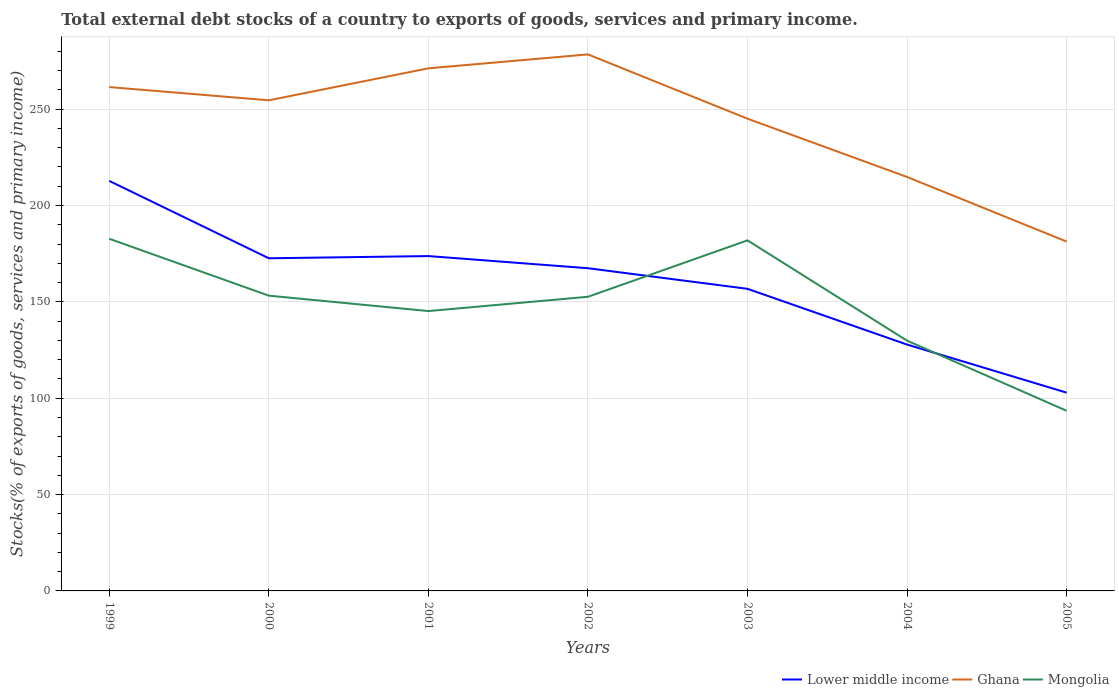How many different coloured lines are there?
Make the answer very short. 3. Is the number of lines equal to the number of legend labels?
Give a very brief answer. Yes. Across all years, what is the maximum total debt stocks in Ghana?
Provide a succinct answer. 181.31. In which year was the total debt stocks in Mongolia maximum?
Make the answer very short. 2005. What is the total total debt stocks in Lower middle income in the graph?
Your answer should be compact. 15.85. What is the difference between the highest and the second highest total debt stocks in Ghana?
Make the answer very short. 97.12. What is the difference between the highest and the lowest total debt stocks in Lower middle income?
Keep it short and to the point. 4. How many lines are there?
Make the answer very short. 3. How many years are there in the graph?
Keep it short and to the point. 7. Are the values on the major ticks of Y-axis written in scientific E-notation?
Your response must be concise. No. Does the graph contain any zero values?
Keep it short and to the point. No. Where does the legend appear in the graph?
Keep it short and to the point. Bottom right. How are the legend labels stacked?
Offer a terse response. Horizontal. What is the title of the graph?
Keep it short and to the point. Total external debt stocks of a country to exports of goods, services and primary income. Does "Timor-Leste" appear as one of the legend labels in the graph?
Give a very brief answer. No. What is the label or title of the X-axis?
Give a very brief answer. Years. What is the label or title of the Y-axis?
Offer a very short reply. Stocks(% of exports of goods, services and primary income). What is the Stocks(% of exports of goods, services and primary income) in Lower middle income in 1999?
Provide a succinct answer. 212.78. What is the Stocks(% of exports of goods, services and primary income) in Ghana in 1999?
Ensure brevity in your answer.  261.48. What is the Stocks(% of exports of goods, services and primary income) in Mongolia in 1999?
Provide a succinct answer. 182.75. What is the Stocks(% of exports of goods, services and primary income) of Lower middle income in 2000?
Keep it short and to the point. 172.63. What is the Stocks(% of exports of goods, services and primary income) in Ghana in 2000?
Your answer should be very brief. 254.61. What is the Stocks(% of exports of goods, services and primary income) of Mongolia in 2000?
Offer a terse response. 153.23. What is the Stocks(% of exports of goods, services and primary income) in Lower middle income in 2001?
Offer a terse response. 173.77. What is the Stocks(% of exports of goods, services and primary income) of Ghana in 2001?
Make the answer very short. 271.2. What is the Stocks(% of exports of goods, services and primary income) of Mongolia in 2001?
Provide a succinct answer. 145.24. What is the Stocks(% of exports of goods, services and primary income) in Lower middle income in 2002?
Keep it short and to the point. 167.47. What is the Stocks(% of exports of goods, services and primary income) of Ghana in 2002?
Make the answer very short. 278.43. What is the Stocks(% of exports of goods, services and primary income) of Mongolia in 2002?
Ensure brevity in your answer.  152.65. What is the Stocks(% of exports of goods, services and primary income) in Lower middle income in 2003?
Your answer should be very brief. 156.78. What is the Stocks(% of exports of goods, services and primary income) in Ghana in 2003?
Offer a very short reply. 245.07. What is the Stocks(% of exports of goods, services and primary income) in Mongolia in 2003?
Your response must be concise. 181.92. What is the Stocks(% of exports of goods, services and primary income) of Lower middle income in 2004?
Offer a very short reply. 127.84. What is the Stocks(% of exports of goods, services and primary income) of Ghana in 2004?
Ensure brevity in your answer.  214.82. What is the Stocks(% of exports of goods, services and primary income) of Mongolia in 2004?
Make the answer very short. 129.87. What is the Stocks(% of exports of goods, services and primary income) in Lower middle income in 2005?
Your answer should be compact. 102.9. What is the Stocks(% of exports of goods, services and primary income) of Ghana in 2005?
Your answer should be compact. 181.31. What is the Stocks(% of exports of goods, services and primary income) in Mongolia in 2005?
Your answer should be very brief. 93.48. Across all years, what is the maximum Stocks(% of exports of goods, services and primary income) of Lower middle income?
Your response must be concise. 212.78. Across all years, what is the maximum Stocks(% of exports of goods, services and primary income) of Ghana?
Make the answer very short. 278.43. Across all years, what is the maximum Stocks(% of exports of goods, services and primary income) in Mongolia?
Your answer should be very brief. 182.75. Across all years, what is the minimum Stocks(% of exports of goods, services and primary income) in Lower middle income?
Keep it short and to the point. 102.9. Across all years, what is the minimum Stocks(% of exports of goods, services and primary income) in Ghana?
Offer a very short reply. 181.31. Across all years, what is the minimum Stocks(% of exports of goods, services and primary income) of Mongolia?
Ensure brevity in your answer.  93.48. What is the total Stocks(% of exports of goods, services and primary income) in Lower middle income in the graph?
Offer a terse response. 1114.18. What is the total Stocks(% of exports of goods, services and primary income) in Ghana in the graph?
Your answer should be compact. 1706.92. What is the total Stocks(% of exports of goods, services and primary income) in Mongolia in the graph?
Offer a very short reply. 1039.14. What is the difference between the Stocks(% of exports of goods, services and primary income) of Lower middle income in 1999 and that in 2000?
Offer a terse response. 40.16. What is the difference between the Stocks(% of exports of goods, services and primary income) in Ghana in 1999 and that in 2000?
Make the answer very short. 6.87. What is the difference between the Stocks(% of exports of goods, services and primary income) in Mongolia in 1999 and that in 2000?
Provide a short and direct response. 29.53. What is the difference between the Stocks(% of exports of goods, services and primary income) in Lower middle income in 1999 and that in 2001?
Ensure brevity in your answer.  39.01. What is the difference between the Stocks(% of exports of goods, services and primary income) of Ghana in 1999 and that in 2001?
Your response must be concise. -9.73. What is the difference between the Stocks(% of exports of goods, services and primary income) in Mongolia in 1999 and that in 2001?
Make the answer very short. 37.52. What is the difference between the Stocks(% of exports of goods, services and primary income) of Lower middle income in 1999 and that in 2002?
Make the answer very short. 45.31. What is the difference between the Stocks(% of exports of goods, services and primary income) in Ghana in 1999 and that in 2002?
Your response must be concise. -16.96. What is the difference between the Stocks(% of exports of goods, services and primary income) in Mongolia in 1999 and that in 2002?
Your answer should be very brief. 30.11. What is the difference between the Stocks(% of exports of goods, services and primary income) of Lower middle income in 1999 and that in 2003?
Make the answer very short. 56.01. What is the difference between the Stocks(% of exports of goods, services and primary income) of Ghana in 1999 and that in 2003?
Provide a short and direct response. 16.41. What is the difference between the Stocks(% of exports of goods, services and primary income) of Mongolia in 1999 and that in 2003?
Make the answer very short. 0.83. What is the difference between the Stocks(% of exports of goods, services and primary income) of Lower middle income in 1999 and that in 2004?
Provide a succinct answer. 84.94. What is the difference between the Stocks(% of exports of goods, services and primary income) in Ghana in 1999 and that in 2004?
Your response must be concise. 46.65. What is the difference between the Stocks(% of exports of goods, services and primary income) in Mongolia in 1999 and that in 2004?
Provide a short and direct response. 52.88. What is the difference between the Stocks(% of exports of goods, services and primary income) in Lower middle income in 1999 and that in 2005?
Keep it short and to the point. 109.88. What is the difference between the Stocks(% of exports of goods, services and primary income) of Ghana in 1999 and that in 2005?
Your answer should be compact. 80.16. What is the difference between the Stocks(% of exports of goods, services and primary income) in Mongolia in 1999 and that in 2005?
Keep it short and to the point. 89.27. What is the difference between the Stocks(% of exports of goods, services and primary income) of Lower middle income in 2000 and that in 2001?
Your response must be concise. -1.14. What is the difference between the Stocks(% of exports of goods, services and primary income) in Ghana in 2000 and that in 2001?
Your answer should be compact. -16.6. What is the difference between the Stocks(% of exports of goods, services and primary income) in Mongolia in 2000 and that in 2001?
Provide a short and direct response. 7.99. What is the difference between the Stocks(% of exports of goods, services and primary income) of Lower middle income in 2000 and that in 2002?
Offer a terse response. 5.16. What is the difference between the Stocks(% of exports of goods, services and primary income) in Ghana in 2000 and that in 2002?
Make the answer very short. -23.83. What is the difference between the Stocks(% of exports of goods, services and primary income) in Mongolia in 2000 and that in 2002?
Your response must be concise. 0.58. What is the difference between the Stocks(% of exports of goods, services and primary income) of Lower middle income in 2000 and that in 2003?
Ensure brevity in your answer.  15.85. What is the difference between the Stocks(% of exports of goods, services and primary income) in Ghana in 2000 and that in 2003?
Your response must be concise. 9.54. What is the difference between the Stocks(% of exports of goods, services and primary income) in Mongolia in 2000 and that in 2003?
Offer a terse response. -28.69. What is the difference between the Stocks(% of exports of goods, services and primary income) in Lower middle income in 2000 and that in 2004?
Offer a very short reply. 44.78. What is the difference between the Stocks(% of exports of goods, services and primary income) of Ghana in 2000 and that in 2004?
Ensure brevity in your answer.  39.78. What is the difference between the Stocks(% of exports of goods, services and primary income) of Mongolia in 2000 and that in 2004?
Your answer should be very brief. 23.36. What is the difference between the Stocks(% of exports of goods, services and primary income) in Lower middle income in 2000 and that in 2005?
Your answer should be very brief. 69.73. What is the difference between the Stocks(% of exports of goods, services and primary income) of Ghana in 2000 and that in 2005?
Make the answer very short. 73.29. What is the difference between the Stocks(% of exports of goods, services and primary income) of Mongolia in 2000 and that in 2005?
Provide a succinct answer. 59.75. What is the difference between the Stocks(% of exports of goods, services and primary income) of Lower middle income in 2001 and that in 2002?
Ensure brevity in your answer.  6.3. What is the difference between the Stocks(% of exports of goods, services and primary income) in Ghana in 2001 and that in 2002?
Offer a terse response. -7.23. What is the difference between the Stocks(% of exports of goods, services and primary income) in Mongolia in 2001 and that in 2002?
Keep it short and to the point. -7.41. What is the difference between the Stocks(% of exports of goods, services and primary income) in Lower middle income in 2001 and that in 2003?
Give a very brief answer. 17. What is the difference between the Stocks(% of exports of goods, services and primary income) in Ghana in 2001 and that in 2003?
Keep it short and to the point. 26.14. What is the difference between the Stocks(% of exports of goods, services and primary income) in Mongolia in 2001 and that in 2003?
Your answer should be compact. -36.69. What is the difference between the Stocks(% of exports of goods, services and primary income) of Lower middle income in 2001 and that in 2004?
Make the answer very short. 45.93. What is the difference between the Stocks(% of exports of goods, services and primary income) in Ghana in 2001 and that in 2004?
Your answer should be very brief. 56.38. What is the difference between the Stocks(% of exports of goods, services and primary income) of Mongolia in 2001 and that in 2004?
Your answer should be compact. 15.37. What is the difference between the Stocks(% of exports of goods, services and primary income) in Lower middle income in 2001 and that in 2005?
Keep it short and to the point. 70.87. What is the difference between the Stocks(% of exports of goods, services and primary income) of Ghana in 2001 and that in 2005?
Offer a very short reply. 89.89. What is the difference between the Stocks(% of exports of goods, services and primary income) in Mongolia in 2001 and that in 2005?
Provide a short and direct response. 51.76. What is the difference between the Stocks(% of exports of goods, services and primary income) in Lower middle income in 2002 and that in 2003?
Your answer should be very brief. 10.69. What is the difference between the Stocks(% of exports of goods, services and primary income) in Ghana in 2002 and that in 2003?
Your answer should be very brief. 33.37. What is the difference between the Stocks(% of exports of goods, services and primary income) of Mongolia in 2002 and that in 2003?
Your answer should be very brief. -29.27. What is the difference between the Stocks(% of exports of goods, services and primary income) of Lower middle income in 2002 and that in 2004?
Make the answer very short. 39.63. What is the difference between the Stocks(% of exports of goods, services and primary income) of Ghana in 2002 and that in 2004?
Provide a succinct answer. 63.61. What is the difference between the Stocks(% of exports of goods, services and primary income) in Mongolia in 2002 and that in 2004?
Ensure brevity in your answer.  22.78. What is the difference between the Stocks(% of exports of goods, services and primary income) in Lower middle income in 2002 and that in 2005?
Ensure brevity in your answer.  64.57. What is the difference between the Stocks(% of exports of goods, services and primary income) of Ghana in 2002 and that in 2005?
Your answer should be compact. 97.12. What is the difference between the Stocks(% of exports of goods, services and primary income) in Mongolia in 2002 and that in 2005?
Give a very brief answer. 59.17. What is the difference between the Stocks(% of exports of goods, services and primary income) of Lower middle income in 2003 and that in 2004?
Provide a short and direct response. 28.93. What is the difference between the Stocks(% of exports of goods, services and primary income) of Ghana in 2003 and that in 2004?
Provide a succinct answer. 30.24. What is the difference between the Stocks(% of exports of goods, services and primary income) in Mongolia in 2003 and that in 2004?
Keep it short and to the point. 52.05. What is the difference between the Stocks(% of exports of goods, services and primary income) of Lower middle income in 2003 and that in 2005?
Make the answer very short. 53.87. What is the difference between the Stocks(% of exports of goods, services and primary income) in Ghana in 2003 and that in 2005?
Offer a terse response. 63.75. What is the difference between the Stocks(% of exports of goods, services and primary income) of Mongolia in 2003 and that in 2005?
Offer a very short reply. 88.44. What is the difference between the Stocks(% of exports of goods, services and primary income) in Lower middle income in 2004 and that in 2005?
Give a very brief answer. 24.94. What is the difference between the Stocks(% of exports of goods, services and primary income) of Ghana in 2004 and that in 2005?
Provide a succinct answer. 33.51. What is the difference between the Stocks(% of exports of goods, services and primary income) of Mongolia in 2004 and that in 2005?
Give a very brief answer. 36.39. What is the difference between the Stocks(% of exports of goods, services and primary income) of Lower middle income in 1999 and the Stocks(% of exports of goods, services and primary income) of Ghana in 2000?
Keep it short and to the point. -41.82. What is the difference between the Stocks(% of exports of goods, services and primary income) in Lower middle income in 1999 and the Stocks(% of exports of goods, services and primary income) in Mongolia in 2000?
Provide a short and direct response. 59.56. What is the difference between the Stocks(% of exports of goods, services and primary income) of Ghana in 1999 and the Stocks(% of exports of goods, services and primary income) of Mongolia in 2000?
Your answer should be very brief. 108.25. What is the difference between the Stocks(% of exports of goods, services and primary income) in Lower middle income in 1999 and the Stocks(% of exports of goods, services and primary income) in Ghana in 2001?
Keep it short and to the point. -58.42. What is the difference between the Stocks(% of exports of goods, services and primary income) of Lower middle income in 1999 and the Stocks(% of exports of goods, services and primary income) of Mongolia in 2001?
Give a very brief answer. 67.55. What is the difference between the Stocks(% of exports of goods, services and primary income) of Ghana in 1999 and the Stocks(% of exports of goods, services and primary income) of Mongolia in 2001?
Your answer should be compact. 116.24. What is the difference between the Stocks(% of exports of goods, services and primary income) of Lower middle income in 1999 and the Stocks(% of exports of goods, services and primary income) of Ghana in 2002?
Provide a succinct answer. -65.65. What is the difference between the Stocks(% of exports of goods, services and primary income) of Lower middle income in 1999 and the Stocks(% of exports of goods, services and primary income) of Mongolia in 2002?
Make the answer very short. 60.14. What is the difference between the Stocks(% of exports of goods, services and primary income) in Ghana in 1999 and the Stocks(% of exports of goods, services and primary income) in Mongolia in 2002?
Provide a succinct answer. 108.83. What is the difference between the Stocks(% of exports of goods, services and primary income) in Lower middle income in 1999 and the Stocks(% of exports of goods, services and primary income) in Ghana in 2003?
Your response must be concise. -32.28. What is the difference between the Stocks(% of exports of goods, services and primary income) in Lower middle income in 1999 and the Stocks(% of exports of goods, services and primary income) in Mongolia in 2003?
Keep it short and to the point. 30.86. What is the difference between the Stocks(% of exports of goods, services and primary income) of Ghana in 1999 and the Stocks(% of exports of goods, services and primary income) of Mongolia in 2003?
Offer a very short reply. 79.55. What is the difference between the Stocks(% of exports of goods, services and primary income) in Lower middle income in 1999 and the Stocks(% of exports of goods, services and primary income) in Ghana in 2004?
Make the answer very short. -2.04. What is the difference between the Stocks(% of exports of goods, services and primary income) of Lower middle income in 1999 and the Stocks(% of exports of goods, services and primary income) of Mongolia in 2004?
Provide a succinct answer. 82.91. What is the difference between the Stocks(% of exports of goods, services and primary income) in Ghana in 1999 and the Stocks(% of exports of goods, services and primary income) in Mongolia in 2004?
Your response must be concise. 131.61. What is the difference between the Stocks(% of exports of goods, services and primary income) in Lower middle income in 1999 and the Stocks(% of exports of goods, services and primary income) in Ghana in 2005?
Offer a terse response. 31.47. What is the difference between the Stocks(% of exports of goods, services and primary income) of Lower middle income in 1999 and the Stocks(% of exports of goods, services and primary income) of Mongolia in 2005?
Offer a very short reply. 119.3. What is the difference between the Stocks(% of exports of goods, services and primary income) of Ghana in 1999 and the Stocks(% of exports of goods, services and primary income) of Mongolia in 2005?
Offer a very short reply. 168. What is the difference between the Stocks(% of exports of goods, services and primary income) in Lower middle income in 2000 and the Stocks(% of exports of goods, services and primary income) in Ghana in 2001?
Offer a terse response. -98.57. What is the difference between the Stocks(% of exports of goods, services and primary income) in Lower middle income in 2000 and the Stocks(% of exports of goods, services and primary income) in Mongolia in 2001?
Offer a very short reply. 27.39. What is the difference between the Stocks(% of exports of goods, services and primary income) in Ghana in 2000 and the Stocks(% of exports of goods, services and primary income) in Mongolia in 2001?
Your response must be concise. 109.37. What is the difference between the Stocks(% of exports of goods, services and primary income) of Lower middle income in 2000 and the Stocks(% of exports of goods, services and primary income) of Ghana in 2002?
Your response must be concise. -105.8. What is the difference between the Stocks(% of exports of goods, services and primary income) of Lower middle income in 2000 and the Stocks(% of exports of goods, services and primary income) of Mongolia in 2002?
Your answer should be compact. 19.98. What is the difference between the Stocks(% of exports of goods, services and primary income) in Ghana in 2000 and the Stocks(% of exports of goods, services and primary income) in Mongolia in 2002?
Give a very brief answer. 101.96. What is the difference between the Stocks(% of exports of goods, services and primary income) in Lower middle income in 2000 and the Stocks(% of exports of goods, services and primary income) in Ghana in 2003?
Ensure brevity in your answer.  -72.44. What is the difference between the Stocks(% of exports of goods, services and primary income) in Lower middle income in 2000 and the Stocks(% of exports of goods, services and primary income) in Mongolia in 2003?
Provide a short and direct response. -9.29. What is the difference between the Stocks(% of exports of goods, services and primary income) in Ghana in 2000 and the Stocks(% of exports of goods, services and primary income) in Mongolia in 2003?
Provide a succinct answer. 72.68. What is the difference between the Stocks(% of exports of goods, services and primary income) of Lower middle income in 2000 and the Stocks(% of exports of goods, services and primary income) of Ghana in 2004?
Offer a terse response. -42.19. What is the difference between the Stocks(% of exports of goods, services and primary income) in Lower middle income in 2000 and the Stocks(% of exports of goods, services and primary income) in Mongolia in 2004?
Offer a terse response. 42.76. What is the difference between the Stocks(% of exports of goods, services and primary income) in Ghana in 2000 and the Stocks(% of exports of goods, services and primary income) in Mongolia in 2004?
Make the answer very short. 124.74. What is the difference between the Stocks(% of exports of goods, services and primary income) of Lower middle income in 2000 and the Stocks(% of exports of goods, services and primary income) of Ghana in 2005?
Ensure brevity in your answer.  -8.69. What is the difference between the Stocks(% of exports of goods, services and primary income) in Lower middle income in 2000 and the Stocks(% of exports of goods, services and primary income) in Mongolia in 2005?
Provide a succinct answer. 79.15. What is the difference between the Stocks(% of exports of goods, services and primary income) of Ghana in 2000 and the Stocks(% of exports of goods, services and primary income) of Mongolia in 2005?
Give a very brief answer. 161.13. What is the difference between the Stocks(% of exports of goods, services and primary income) of Lower middle income in 2001 and the Stocks(% of exports of goods, services and primary income) of Ghana in 2002?
Ensure brevity in your answer.  -104.66. What is the difference between the Stocks(% of exports of goods, services and primary income) in Lower middle income in 2001 and the Stocks(% of exports of goods, services and primary income) in Mongolia in 2002?
Make the answer very short. 21.12. What is the difference between the Stocks(% of exports of goods, services and primary income) of Ghana in 2001 and the Stocks(% of exports of goods, services and primary income) of Mongolia in 2002?
Provide a succinct answer. 118.55. What is the difference between the Stocks(% of exports of goods, services and primary income) of Lower middle income in 2001 and the Stocks(% of exports of goods, services and primary income) of Ghana in 2003?
Provide a succinct answer. -71.29. What is the difference between the Stocks(% of exports of goods, services and primary income) in Lower middle income in 2001 and the Stocks(% of exports of goods, services and primary income) in Mongolia in 2003?
Your response must be concise. -8.15. What is the difference between the Stocks(% of exports of goods, services and primary income) in Ghana in 2001 and the Stocks(% of exports of goods, services and primary income) in Mongolia in 2003?
Your answer should be very brief. 89.28. What is the difference between the Stocks(% of exports of goods, services and primary income) of Lower middle income in 2001 and the Stocks(% of exports of goods, services and primary income) of Ghana in 2004?
Your response must be concise. -41.05. What is the difference between the Stocks(% of exports of goods, services and primary income) in Lower middle income in 2001 and the Stocks(% of exports of goods, services and primary income) in Mongolia in 2004?
Your response must be concise. 43.9. What is the difference between the Stocks(% of exports of goods, services and primary income) of Ghana in 2001 and the Stocks(% of exports of goods, services and primary income) of Mongolia in 2004?
Make the answer very short. 141.33. What is the difference between the Stocks(% of exports of goods, services and primary income) in Lower middle income in 2001 and the Stocks(% of exports of goods, services and primary income) in Ghana in 2005?
Offer a very short reply. -7.54. What is the difference between the Stocks(% of exports of goods, services and primary income) of Lower middle income in 2001 and the Stocks(% of exports of goods, services and primary income) of Mongolia in 2005?
Your answer should be compact. 80.29. What is the difference between the Stocks(% of exports of goods, services and primary income) of Ghana in 2001 and the Stocks(% of exports of goods, services and primary income) of Mongolia in 2005?
Keep it short and to the point. 177.72. What is the difference between the Stocks(% of exports of goods, services and primary income) in Lower middle income in 2002 and the Stocks(% of exports of goods, services and primary income) in Ghana in 2003?
Provide a succinct answer. -77.6. What is the difference between the Stocks(% of exports of goods, services and primary income) of Lower middle income in 2002 and the Stocks(% of exports of goods, services and primary income) of Mongolia in 2003?
Your response must be concise. -14.45. What is the difference between the Stocks(% of exports of goods, services and primary income) of Ghana in 2002 and the Stocks(% of exports of goods, services and primary income) of Mongolia in 2003?
Provide a short and direct response. 96.51. What is the difference between the Stocks(% of exports of goods, services and primary income) of Lower middle income in 2002 and the Stocks(% of exports of goods, services and primary income) of Ghana in 2004?
Make the answer very short. -47.35. What is the difference between the Stocks(% of exports of goods, services and primary income) of Lower middle income in 2002 and the Stocks(% of exports of goods, services and primary income) of Mongolia in 2004?
Your answer should be very brief. 37.6. What is the difference between the Stocks(% of exports of goods, services and primary income) of Ghana in 2002 and the Stocks(% of exports of goods, services and primary income) of Mongolia in 2004?
Provide a succinct answer. 148.56. What is the difference between the Stocks(% of exports of goods, services and primary income) of Lower middle income in 2002 and the Stocks(% of exports of goods, services and primary income) of Ghana in 2005?
Keep it short and to the point. -13.84. What is the difference between the Stocks(% of exports of goods, services and primary income) in Lower middle income in 2002 and the Stocks(% of exports of goods, services and primary income) in Mongolia in 2005?
Ensure brevity in your answer.  73.99. What is the difference between the Stocks(% of exports of goods, services and primary income) of Ghana in 2002 and the Stocks(% of exports of goods, services and primary income) of Mongolia in 2005?
Give a very brief answer. 184.95. What is the difference between the Stocks(% of exports of goods, services and primary income) in Lower middle income in 2003 and the Stocks(% of exports of goods, services and primary income) in Ghana in 2004?
Make the answer very short. -58.05. What is the difference between the Stocks(% of exports of goods, services and primary income) of Lower middle income in 2003 and the Stocks(% of exports of goods, services and primary income) of Mongolia in 2004?
Your response must be concise. 26.91. What is the difference between the Stocks(% of exports of goods, services and primary income) in Ghana in 2003 and the Stocks(% of exports of goods, services and primary income) in Mongolia in 2004?
Your answer should be compact. 115.2. What is the difference between the Stocks(% of exports of goods, services and primary income) of Lower middle income in 2003 and the Stocks(% of exports of goods, services and primary income) of Ghana in 2005?
Your response must be concise. -24.54. What is the difference between the Stocks(% of exports of goods, services and primary income) in Lower middle income in 2003 and the Stocks(% of exports of goods, services and primary income) in Mongolia in 2005?
Ensure brevity in your answer.  63.29. What is the difference between the Stocks(% of exports of goods, services and primary income) in Ghana in 2003 and the Stocks(% of exports of goods, services and primary income) in Mongolia in 2005?
Offer a very short reply. 151.59. What is the difference between the Stocks(% of exports of goods, services and primary income) of Lower middle income in 2004 and the Stocks(% of exports of goods, services and primary income) of Ghana in 2005?
Keep it short and to the point. -53.47. What is the difference between the Stocks(% of exports of goods, services and primary income) of Lower middle income in 2004 and the Stocks(% of exports of goods, services and primary income) of Mongolia in 2005?
Your answer should be compact. 34.36. What is the difference between the Stocks(% of exports of goods, services and primary income) in Ghana in 2004 and the Stocks(% of exports of goods, services and primary income) in Mongolia in 2005?
Give a very brief answer. 121.34. What is the average Stocks(% of exports of goods, services and primary income) in Lower middle income per year?
Your answer should be compact. 159.17. What is the average Stocks(% of exports of goods, services and primary income) in Ghana per year?
Make the answer very short. 243.85. What is the average Stocks(% of exports of goods, services and primary income) in Mongolia per year?
Provide a succinct answer. 148.45. In the year 1999, what is the difference between the Stocks(% of exports of goods, services and primary income) in Lower middle income and Stocks(% of exports of goods, services and primary income) in Ghana?
Your answer should be very brief. -48.69. In the year 1999, what is the difference between the Stocks(% of exports of goods, services and primary income) in Lower middle income and Stocks(% of exports of goods, services and primary income) in Mongolia?
Make the answer very short. 30.03. In the year 1999, what is the difference between the Stocks(% of exports of goods, services and primary income) in Ghana and Stocks(% of exports of goods, services and primary income) in Mongolia?
Ensure brevity in your answer.  78.72. In the year 2000, what is the difference between the Stocks(% of exports of goods, services and primary income) in Lower middle income and Stocks(% of exports of goods, services and primary income) in Ghana?
Keep it short and to the point. -81.98. In the year 2000, what is the difference between the Stocks(% of exports of goods, services and primary income) in Lower middle income and Stocks(% of exports of goods, services and primary income) in Mongolia?
Your answer should be compact. 19.4. In the year 2000, what is the difference between the Stocks(% of exports of goods, services and primary income) of Ghana and Stocks(% of exports of goods, services and primary income) of Mongolia?
Ensure brevity in your answer.  101.38. In the year 2001, what is the difference between the Stocks(% of exports of goods, services and primary income) of Lower middle income and Stocks(% of exports of goods, services and primary income) of Ghana?
Give a very brief answer. -97.43. In the year 2001, what is the difference between the Stocks(% of exports of goods, services and primary income) of Lower middle income and Stocks(% of exports of goods, services and primary income) of Mongolia?
Provide a succinct answer. 28.54. In the year 2001, what is the difference between the Stocks(% of exports of goods, services and primary income) in Ghana and Stocks(% of exports of goods, services and primary income) in Mongolia?
Make the answer very short. 125.97. In the year 2002, what is the difference between the Stocks(% of exports of goods, services and primary income) in Lower middle income and Stocks(% of exports of goods, services and primary income) in Ghana?
Your answer should be compact. -110.96. In the year 2002, what is the difference between the Stocks(% of exports of goods, services and primary income) of Lower middle income and Stocks(% of exports of goods, services and primary income) of Mongolia?
Ensure brevity in your answer.  14.82. In the year 2002, what is the difference between the Stocks(% of exports of goods, services and primary income) in Ghana and Stocks(% of exports of goods, services and primary income) in Mongolia?
Offer a terse response. 125.78. In the year 2003, what is the difference between the Stocks(% of exports of goods, services and primary income) of Lower middle income and Stocks(% of exports of goods, services and primary income) of Ghana?
Ensure brevity in your answer.  -88.29. In the year 2003, what is the difference between the Stocks(% of exports of goods, services and primary income) of Lower middle income and Stocks(% of exports of goods, services and primary income) of Mongolia?
Provide a short and direct response. -25.15. In the year 2003, what is the difference between the Stocks(% of exports of goods, services and primary income) in Ghana and Stocks(% of exports of goods, services and primary income) in Mongolia?
Keep it short and to the point. 63.14. In the year 2004, what is the difference between the Stocks(% of exports of goods, services and primary income) of Lower middle income and Stocks(% of exports of goods, services and primary income) of Ghana?
Offer a terse response. -86.98. In the year 2004, what is the difference between the Stocks(% of exports of goods, services and primary income) in Lower middle income and Stocks(% of exports of goods, services and primary income) in Mongolia?
Make the answer very short. -2.03. In the year 2004, what is the difference between the Stocks(% of exports of goods, services and primary income) of Ghana and Stocks(% of exports of goods, services and primary income) of Mongolia?
Give a very brief answer. 84.95. In the year 2005, what is the difference between the Stocks(% of exports of goods, services and primary income) in Lower middle income and Stocks(% of exports of goods, services and primary income) in Ghana?
Make the answer very short. -78.41. In the year 2005, what is the difference between the Stocks(% of exports of goods, services and primary income) in Lower middle income and Stocks(% of exports of goods, services and primary income) in Mongolia?
Your answer should be compact. 9.42. In the year 2005, what is the difference between the Stocks(% of exports of goods, services and primary income) of Ghana and Stocks(% of exports of goods, services and primary income) of Mongolia?
Give a very brief answer. 87.83. What is the ratio of the Stocks(% of exports of goods, services and primary income) of Lower middle income in 1999 to that in 2000?
Your response must be concise. 1.23. What is the ratio of the Stocks(% of exports of goods, services and primary income) in Ghana in 1999 to that in 2000?
Ensure brevity in your answer.  1.03. What is the ratio of the Stocks(% of exports of goods, services and primary income) in Mongolia in 1999 to that in 2000?
Your response must be concise. 1.19. What is the ratio of the Stocks(% of exports of goods, services and primary income) in Lower middle income in 1999 to that in 2001?
Offer a terse response. 1.22. What is the ratio of the Stocks(% of exports of goods, services and primary income) in Ghana in 1999 to that in 2001?
Provide a short and direct response. 0.96. What is the ratio of the Stocks(% of exports of goods, services and primary income) in Mongolia in 1999 to that in 2001?
Provide a short and direct response. 1.26. What is the ratio of the Stocks(% of exports of goods, services and primary income) in Lower middle income in 1999 to that in 2002?
Your answer should be compact. 1.27. What is the ratio of the Stocks(% of exports of goods, services and primary income) in Ghana in 1999 to that in 2002?
Make the answer very short. 0.94. What is the ratio of the Stocks(% of exports of goods, services and primary income) of Mongolia in 1999 to that in 2002?
Your answer should be compact. 1.2. What is the ratio of the Stocks(% of exports of goods, services and primary income) in Lower middle income in 1999 to that in 2003?
Your answer should be very brief. 1.36. What is the ratio of the Stocks(% of exports of goods, services and primary income) in Ghana in 1999 to that in 2003?
Your response must be concise. 1.07. What is the ratio of the Stocks(% of exports of goods, services and primary income) of Lower middle income in 1999 to that in 2004?
Your answer should be compact. 1.66. What is the ratio of the Stocks(% of exports of goods, services and primary income) in Ghana in 1999 to that in 2004?
Offer a terse response. 1.22. What is the ratio of the Stocks(% of exports of goods, services and primary income) in Mongolia in 1999 to that in 2004?
Provide a succinct answer. 1.41. What is the ratio of the Stocks(% of exports of goods, services and primary income) in Lower middle income in 1999 to that in 2005?
Offer a very short reply. 2.07. What is the ratio of the Stocks(% of exports of goods, services and primary income) of Ghana in 1999 to that in 2005?
Keep it short and to the point. 1.44. What is the ratio of the Stocks(% of exports of goods, services and primary income) in Mongolia in 1999 to that in 2005?
Offer a terse response. 1.96. What is the ratio of the Stocks(% of exports of goods, services and primary income) of Lower middle income in 2000 to that in 2001?
Your response must be concise. 0.99. What is the ratio of the Stocks(% of exports of goods, services and primary income) in Ghana in 2000 to that in 2001?
Provide a short and direct response. 0.94. What is the ratio of the Stocks(% of exports of goods, services and primary income) of Mongolia in 2000 to that in 2001?
Offer a terse response. 1.05. What is the ratio of the Stocks(% of exports of goods, services and primary income) of Lower middle income in 2000 to that in 2002?
Your response must be concise. 1.03. What is the ratio of the Stocks(% of exports of goods, services and primary income) of Ghana in 2000 to that in 2002?
Provide a succinct answer. 0.91. What is the ratio of the Stocks(% of exports of goods, services and primary income) in Lower middle income in 2000 to that in 2003?
Your answer should be very brief. 1.1. What is the ratio of the Stocks(% of exports of goods, services and primary income) in Ghana in 2000 to that in 2003?
Give a very brief answer. 1.04. What is the ratio of the Stocks(% of exports of goods, services and primary income) of Mongolia in 2000 to that in 2003?
Your answer should be very brief. 0.84. What is the ratio of the Stocks(% of exports of goods, services and primary income) of Lower middle income in 2000 to that in 2004?
Keep it short and to the point. 1.35. What is the ratio of the Stocks(% of exports of goods, services and primary income) in Ghana in 2000 to that in 2004?
Give a very brief answer. 1.19. What is the ratio of the Stocks(% of exports of goods, services and primary income) in Mongolia in 2000 to that in 2004?
Make the answer very short. 1.18. What is the ratio of the Stocks(% of exports of goods, services and primary income) of Lower middle income in 2000 to that in 2005?
Offer a terse response. 1.68. What is the ratio of the Stocks(% of exports of goods, services and primary income) of Ghana in 2000 to that in 2005?
Keep it short and to the point. 1.4. What is the ratio of the Stocks(% of exports of goods, services and primary income) of Mongolia in 2000 to that in 2005?
Provide a short and direct response. 1.64. What is the ratio of the Stocks(% of exports of goods, services and primary income) of Lower middle income in 2001 to that in 2002?
Ensure brevity in your answer.  1.04. What is the ratio of the Stocks(% of exports of goods, services and primary income) of Mongolia in 2001 to that in 2002?
Offer a terse response. 0.95. What is the ratio of the Stocks(% of exports of goods, services and primary income) of Lower middle income in 2001 to that in 2003?
Keep it short and to the point. 1.11. What is the ratio of the Stocks(% of exports of goods, services and primary income) of Ghana in 2001 to that in 2003?
Offer a terse response. 1.11. What is the ratio of the Stocks(% of exports of goods, services and primary income) in Mongolia in 2001 to that in 2003?
Ensure brevity in your answer.  0.8. What is the ratio of the Stocks(% of exports of goods, services and primary income) in Lower middle income in 2001 to that in 2004?
Offer a terse response. 1.36. What is the ratio of the Stocks(% of exports of goods, services and primary income) in Ghana in 2001 to that in 2004?
Provide a succinct answer. 1.26. What is the ratio of the Stocks(% of exports of goods, services and primary income) in Mongolia in 2001 to that in 2004?
Give a very brief answer. 1.12. What is the ratio of the Stocks(% of exports of goods, services and primary income) in Lower middle income in 2001 to that in 2005?
Offer a terse response. 1.69. What is the ratio of the Stocks(% of exports of goods, services and primary income) of Ghana in 2001 to that in 2005?
Keep it short and to the point. 1.5. What is the ratio of the Stocks(% of exports of goods, services and primary income) in Mongolia in 2001 to that in 2005?
Ensure brevity in your answer.  1.55. What is the ratio of the Stocks(% of exports of goods, services and primary income) in Lower middle income in 2002 to that in 2003?
Offer a very short reply. 1.07. What is the ratio of the Stocks(% of exports of goods, services and primary income) of Ghana in 2002 to that in 2003?
Give a very brief answer. 1.14. What is the ratio of the Stocks(% of exports of goods, services and primary income) of Mongolia in 2002 to that in 2003?
Keep it short and to the point. 0.84. What is the ratio of the Stocks(% of exports of goods, services and primary income) in Lower middle income in 2002 to that in 2004?
Your answer should be compact. 1.31. What is the ratio of the Stocks(% of exports of goods, services and primary income) in Ghana in 2002 to that in 2004?
Offer a very short reply. 1.3. What is the ratio of the Stocks(% of exports of goods, services and primary income) of Mongolia in 2002 to that in 2004?
Give a very brief answer. 1.18. What is the ratio of the Stocks(% of exports of goods, services and primary income) in Lower middle income in 2002 to that in 2005?
Offer a terse response. 1.63. What is the ratio of the Stocks(% of exports of goods, services and primary income) of Ghana in 2002 to that in 2005?
Offer a very short reply. 1.54. What is the ratio of the Stocks(% of exports of goods, services and primary income) of Mongolia in 2002 to that in 2005?
Give a very brief answer. 1.63. What is the ratio of the Stocks(% of exports of goods, services and primary income) of Lower middle income in 2003 to that in 2004?
Keep it short and to the point. 1.23. What is the ratio of the Stocks(% of exports of goods, services and primary income) in Ghana in 2003 to that in 2004?
Give a very brief answer. 1.14. What is the ratio of the Stocks(% of exports of goods, services and primary income) in Mongolia in 2003 to that in 2004?
Your answer should be very brief. 1.4. What is the ratio of the Stocks(% of exports of goods, services and primary income) of Lower middle income in 2003 to that in 2005?
Provide a succinct answer. 1.52. What is the ratio of the Stocks(% of exports of goods, services and primary income) in Ghana in 2003 to that in 2005?
Offer a terse response. 1.35. What is the ratio of the Stocks(% of exports of goods, services and primary income) in Mongolia in 2003 to that in 2005?
Provide a short and direct response. 1.95. What is the ratio of the Stocks(% of exports of goods, services and primary income) of Lower middle income in 2004 to that in 2005?
Keep it short and to the point. 1.24. What is the ratio of the Stocks(% of exports of goods, services and primary income) of Ghana in 2004 to that in 2005?
Give a very brief answer. 1.18. What is the ratio of the Stocks(% of exports of goods, services and primary income) in Mongolia in 2004 to that in 2005?
Keep it short and to the point. 1.39. What is the difference between the highest and the second highest Stocks(% of exports of goods, services and primary income) of Lower middle income?
Ensure brevity in your answer.  39.01. What is the difference between the highest and the second highest Stocks(% of exports of goods, services and primary income) in Ghana?
Offer a very short reply. 7.23. What is the difference between the highest and the second highest Stocks(% of exports of goods, services and primary income) of Mongolia?
Offer a very short reply. 0.83. What is the difference between the highest and the lowest Stocks(% of exports of goods, services and primary income) of Lower middle income?
Your answer should be very brief. 109.88. What is the difference between the highest and the lowest Stocks(% of exports of goods, services and primary income) of Ghana?
Your response must be concise. 97.12. What is the difference between the highest and the lowest Stocks(% of exports of goods, services and primary income) of Mongolia?
Offer a very short reply. 89.27. 